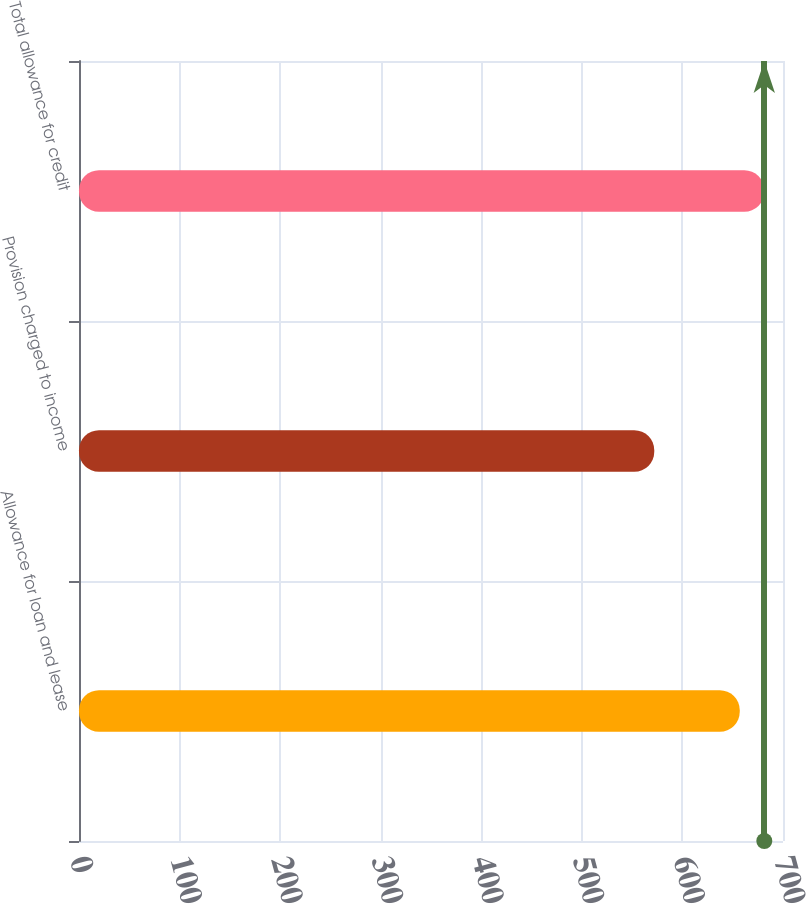<chart> <loc_0><loc_0><loc_500><loc_500><bar_chart><fcel>Allowance for loan and lease<fcel>Provision charged to income<fcel>Total allowance for credit<nl><fcel>657<fcel>572<fcel>681.4<nl></chart> 